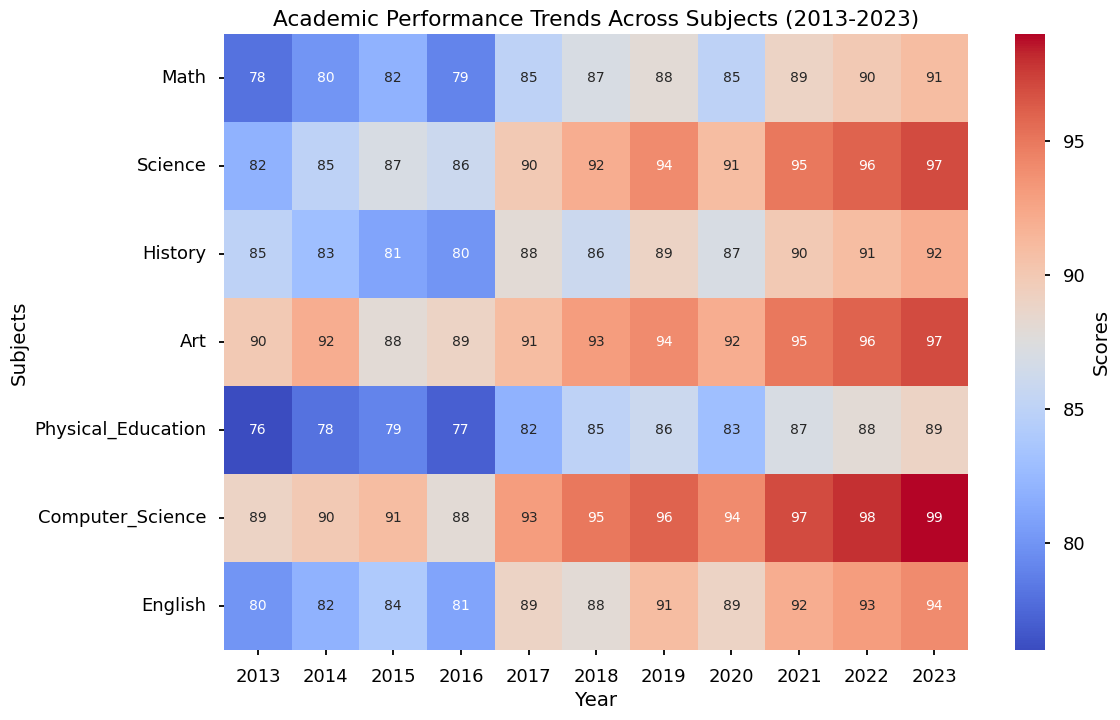What is the average score in Computer Science over the decade? First, extract the Computer Science scores from each year which are [89, 90, 91, 88, 93, 95, 96, 94, 97, 98, 99]. Then, sum these scores (89 + 90 + 91 + 88 + 93 + 95 + 96 + 94 + 97 + 98 + 99 = 1030). Finally, divide by the number of years (1030/11).
Answer: 93.64 Which subject showed the most improvement in scores from 2013 to 2023? Compare the values of each subject in 2013 and 2023. Calculate the difference for each subject: Math (91-78=13), Science (97-82=15), History (92-85=7), Art (97-90=7), Physical Education (89-76=13), Computer Science (99-89=10), English (94-80=14). The subject with the highest difference is Science.
Answer: Science In which year did Art have its highest score, and what was that score? Look at the Art scores across the years and identify the highest value. Art scores: [90, 92, 88, 89, 91, 93, 94, 92, 95, 96, 97]. The highest score is 97 which occurred in 2023.
Answer: 2023, 97 What is the overall trend in Math scores over the decade? Observe the Math scores for each year: [78, 80, 82, 79, 85, 87, 88, 85, 89, 90, 91]. Notice the general increase with slight decreases; overall, the trend is upward.
Answer: Upward How many years did English scores remain the same as the previous year? Look at the English scores for each year: [80, 82, 84, 81, 89, 88, 91, 89, 92, 93, 94]. None of the scores are the same as the previous year.
Answer: 0 